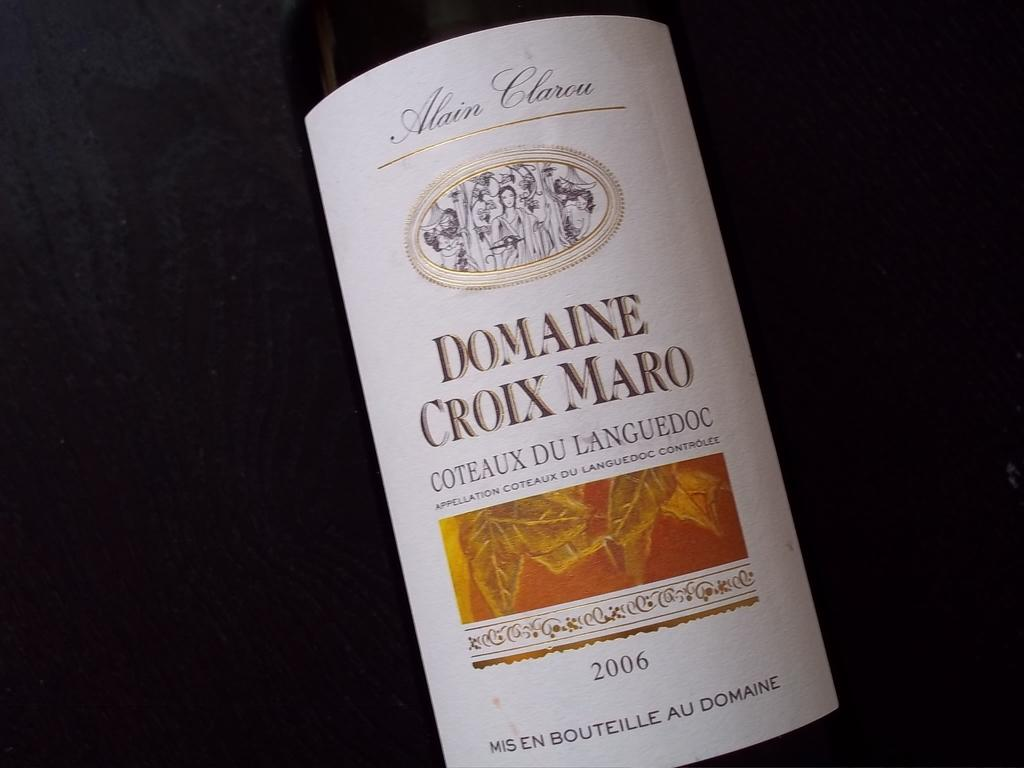<image>
Describe the image concisely. Label on a bottle of Domaine Croix Maro wine. 